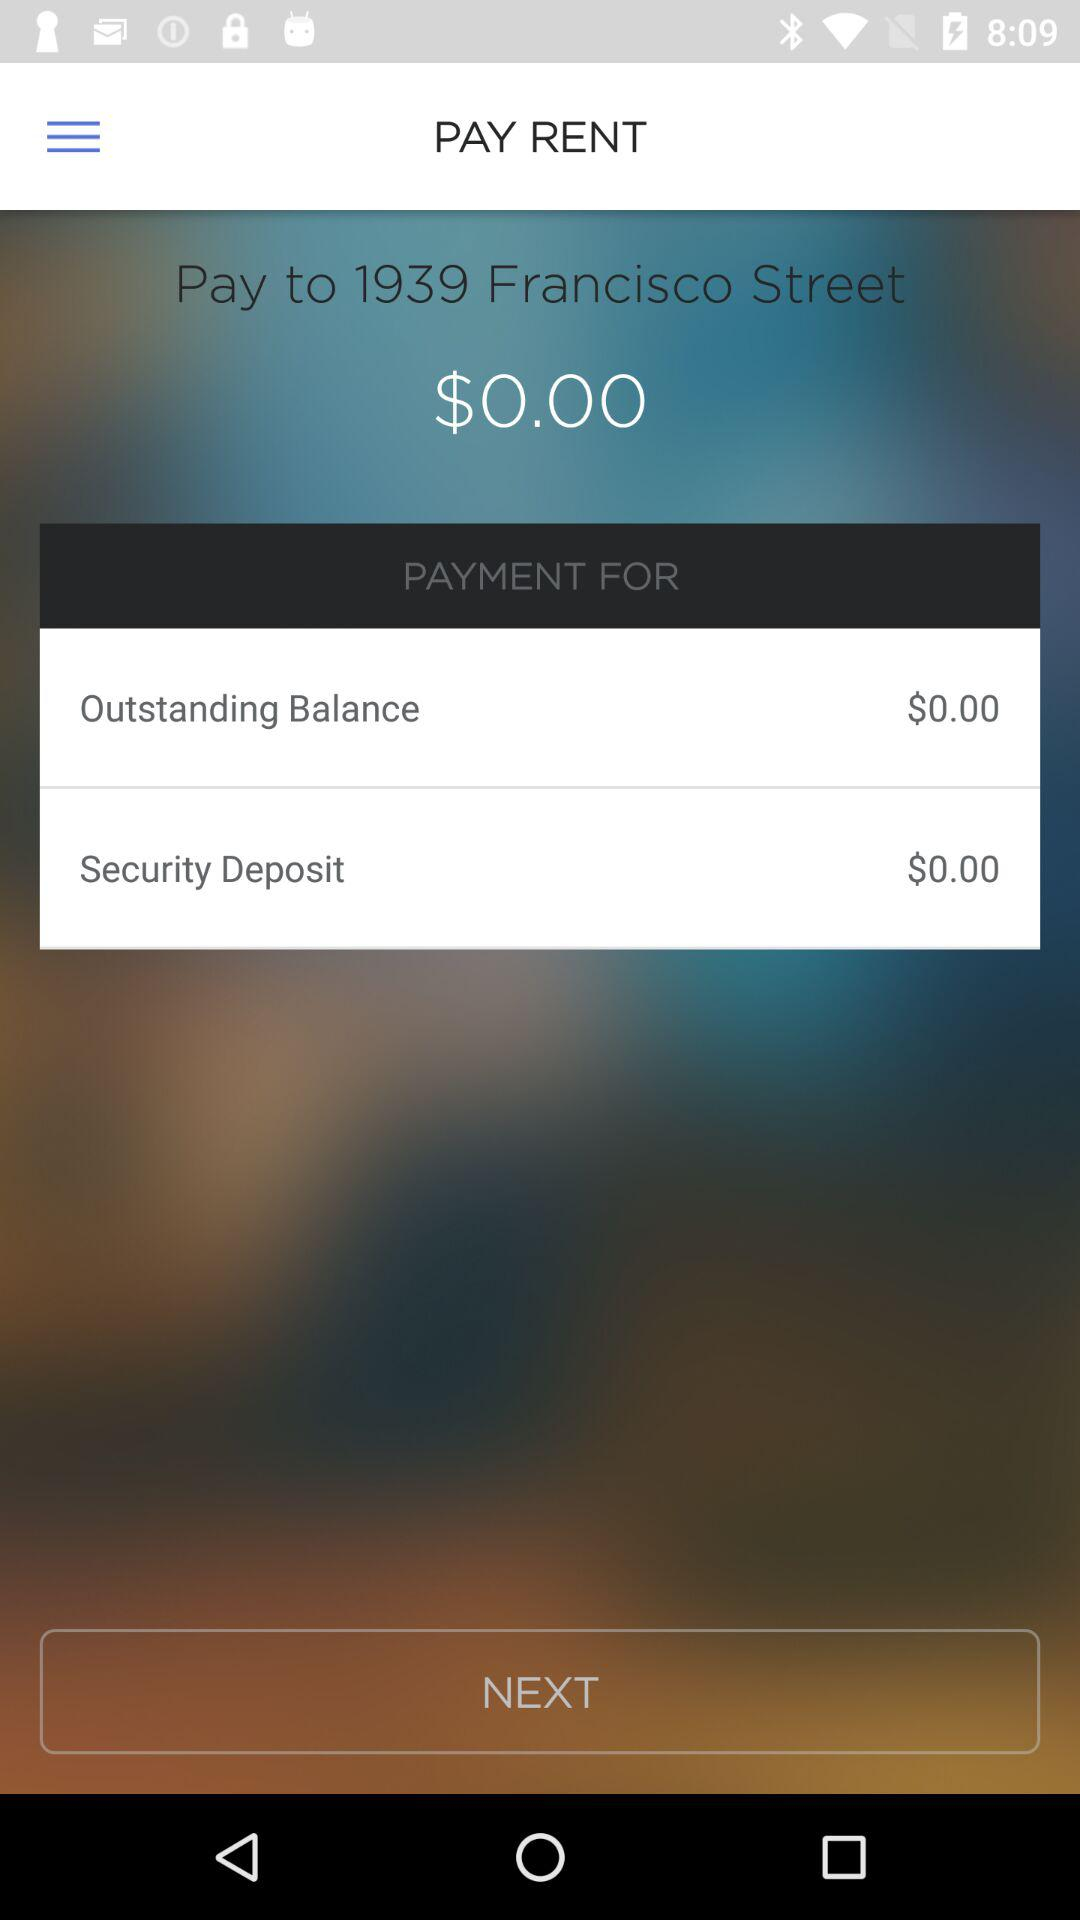How much is the security deposit? The security deposit is $0. 